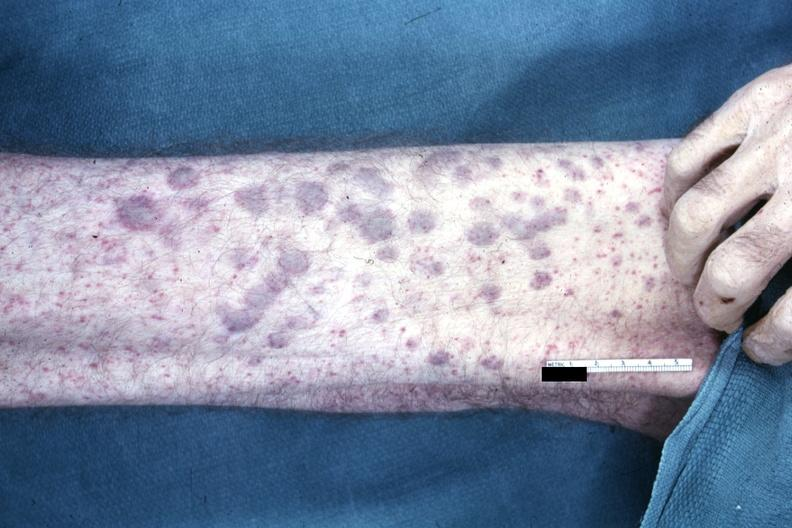where is this?
Answer the question using a single word or phrase. Skin 